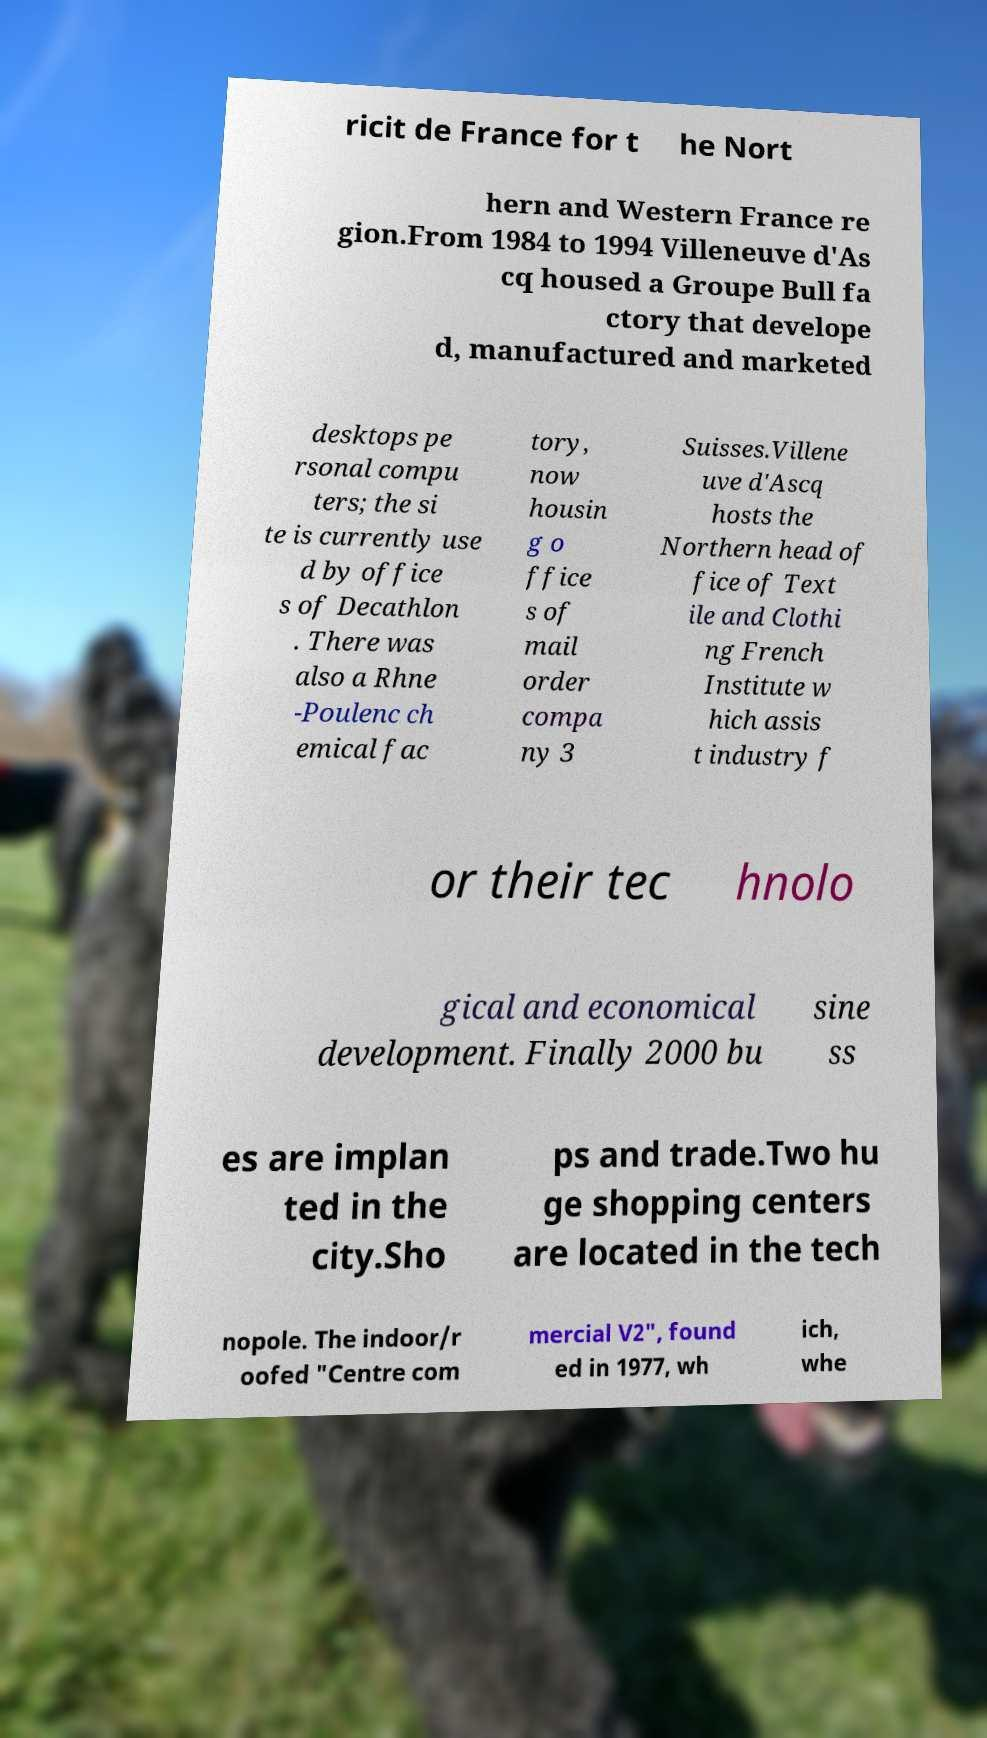Can you read and provide the text displayed in the image?This photo seems to have some interesting text. Can you extract and type it out for me? ricit de France for t he Nort hern and Western France re gion.From 1984 to 1994 Villeneuve d'As cq housed a Groupe Bull fa ctory that develope d, manufactured and marketed desktops pe rsonal compu ters; the si te is currently use d by office s of Decathlon . There was also a Rhne -Poulenc ch emical fac tory, now housin g o ffice s of mail order compa ny 3 Suisses.Villene uve d'Ascq hosts the Northern head of fice of Text ile and Clothi ng French Institute w hich assis t industry f or their tec hnolo gical and economical development. Finally 2000 bu sine ss es are implan ted in the city.Sho ps and trade.Two hu ge shopping centers are located in the tech nopole. The indoor/r oofed "Centre com mercial V2", found ed in 1977, wh ich, whe 